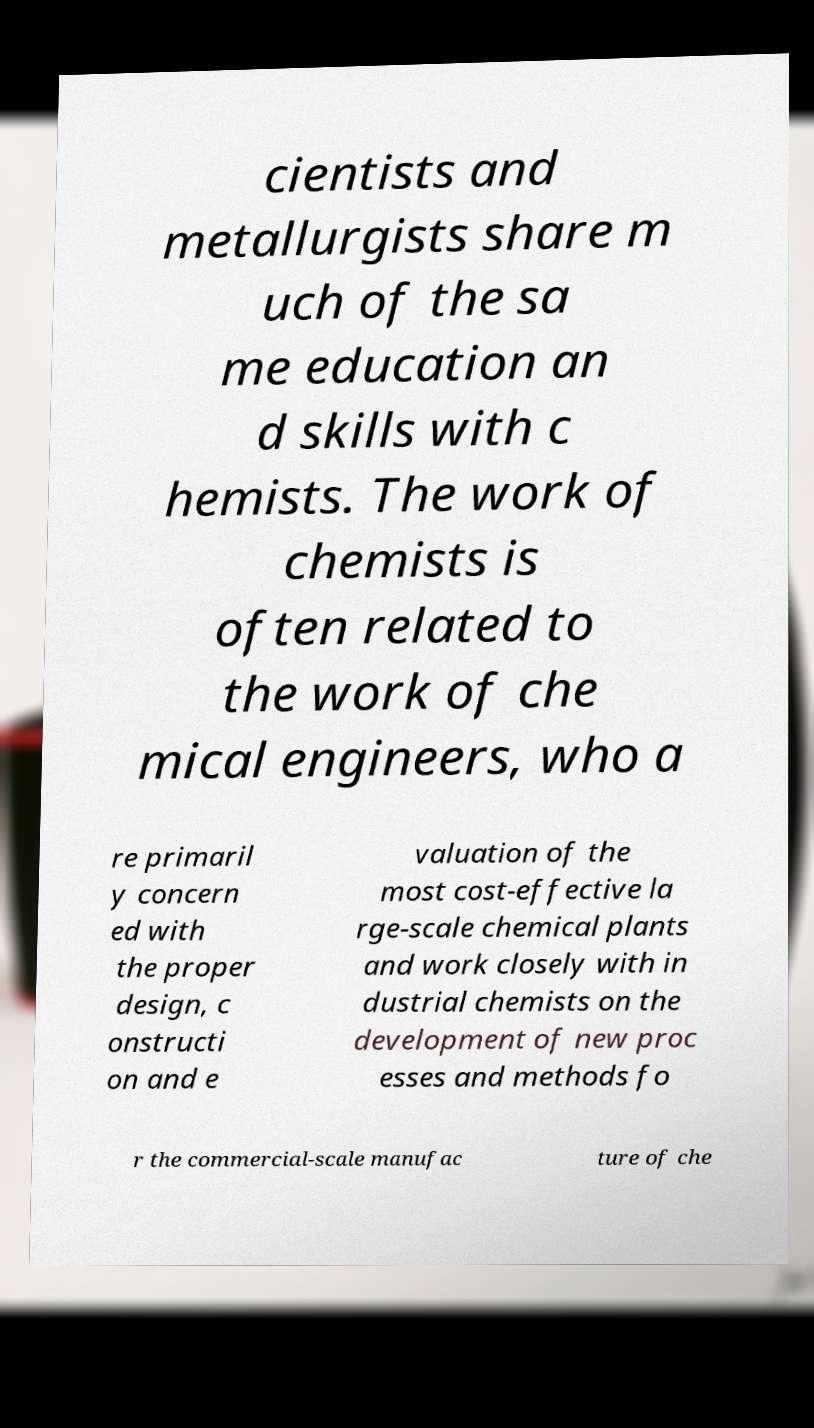Could you extract and type out the text from this image? cientists and metallurgists share m uch of the sa me education an d skills with c hemists. The work of chemists is often related to the work of che mical engineers, who a re primaril y concern ed with the proper design, c onstructi on and e valuation of the most cost-effective la rge-scale chemical plants and work closely with in dustrial chemists on the development of new proc esses and methods fo r the commercial-scale manufac ture of che 